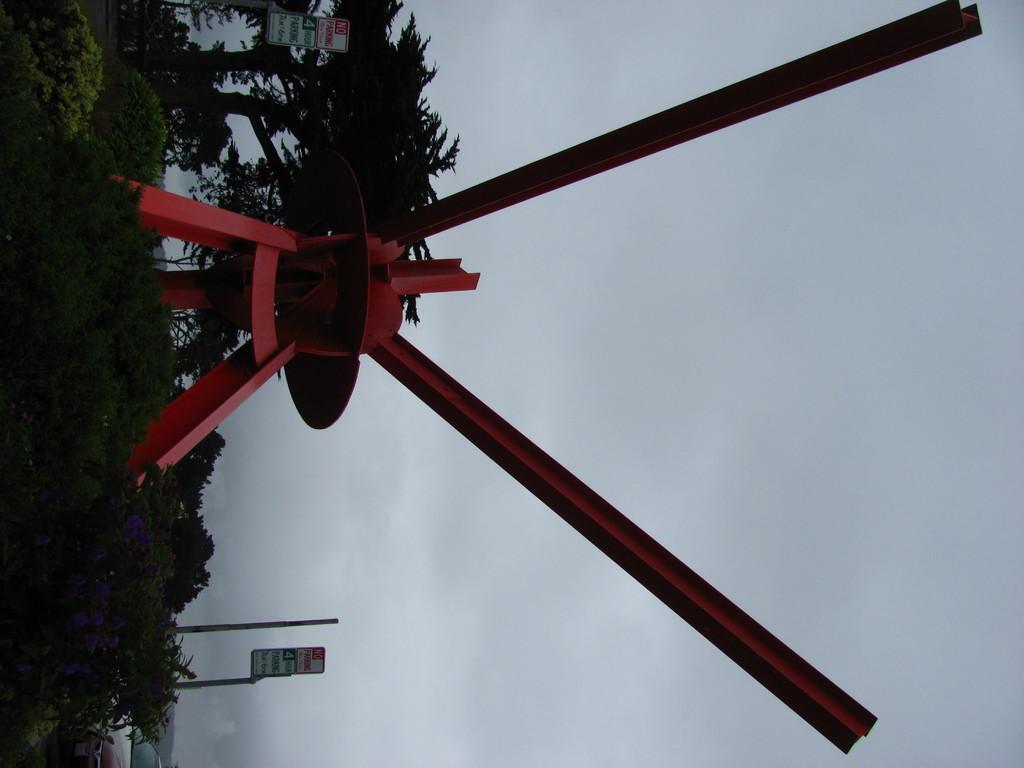In one or two sentences, can you explain what this image depicts? In the center of the image, we can see a turbine and in the background, there are trees and we can see some sign boards and name boards. 